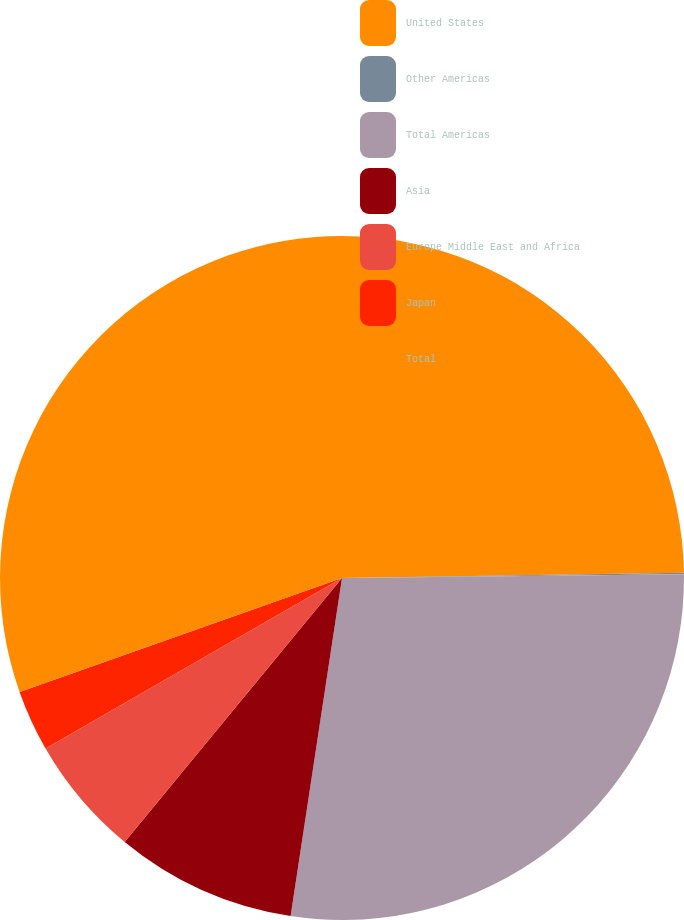Convert chart. <chart><loc_0><loc_0><loc_500><loc_500><pie_chart><fcel>United States<fcel>Other Americas<fcel>Total Americas<fcel>Asia<fcel>Europe Middle East and Africa<fcel>Japan<fcel>Total<nl><fcel>24.75%<fcel>0.07%<fcel>27.58%<fcel>8.56%<fcel>5.73%<fcel>2.9%<fcel>30.41%<nl></chart> 